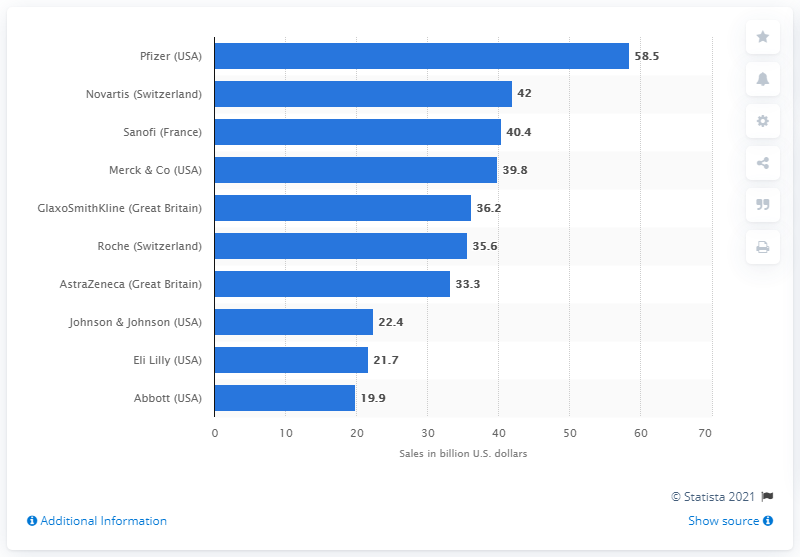Give some essential details in this illustration. Roche generated a total revenue of 35.6 billion U.S. dollars in 2010. 